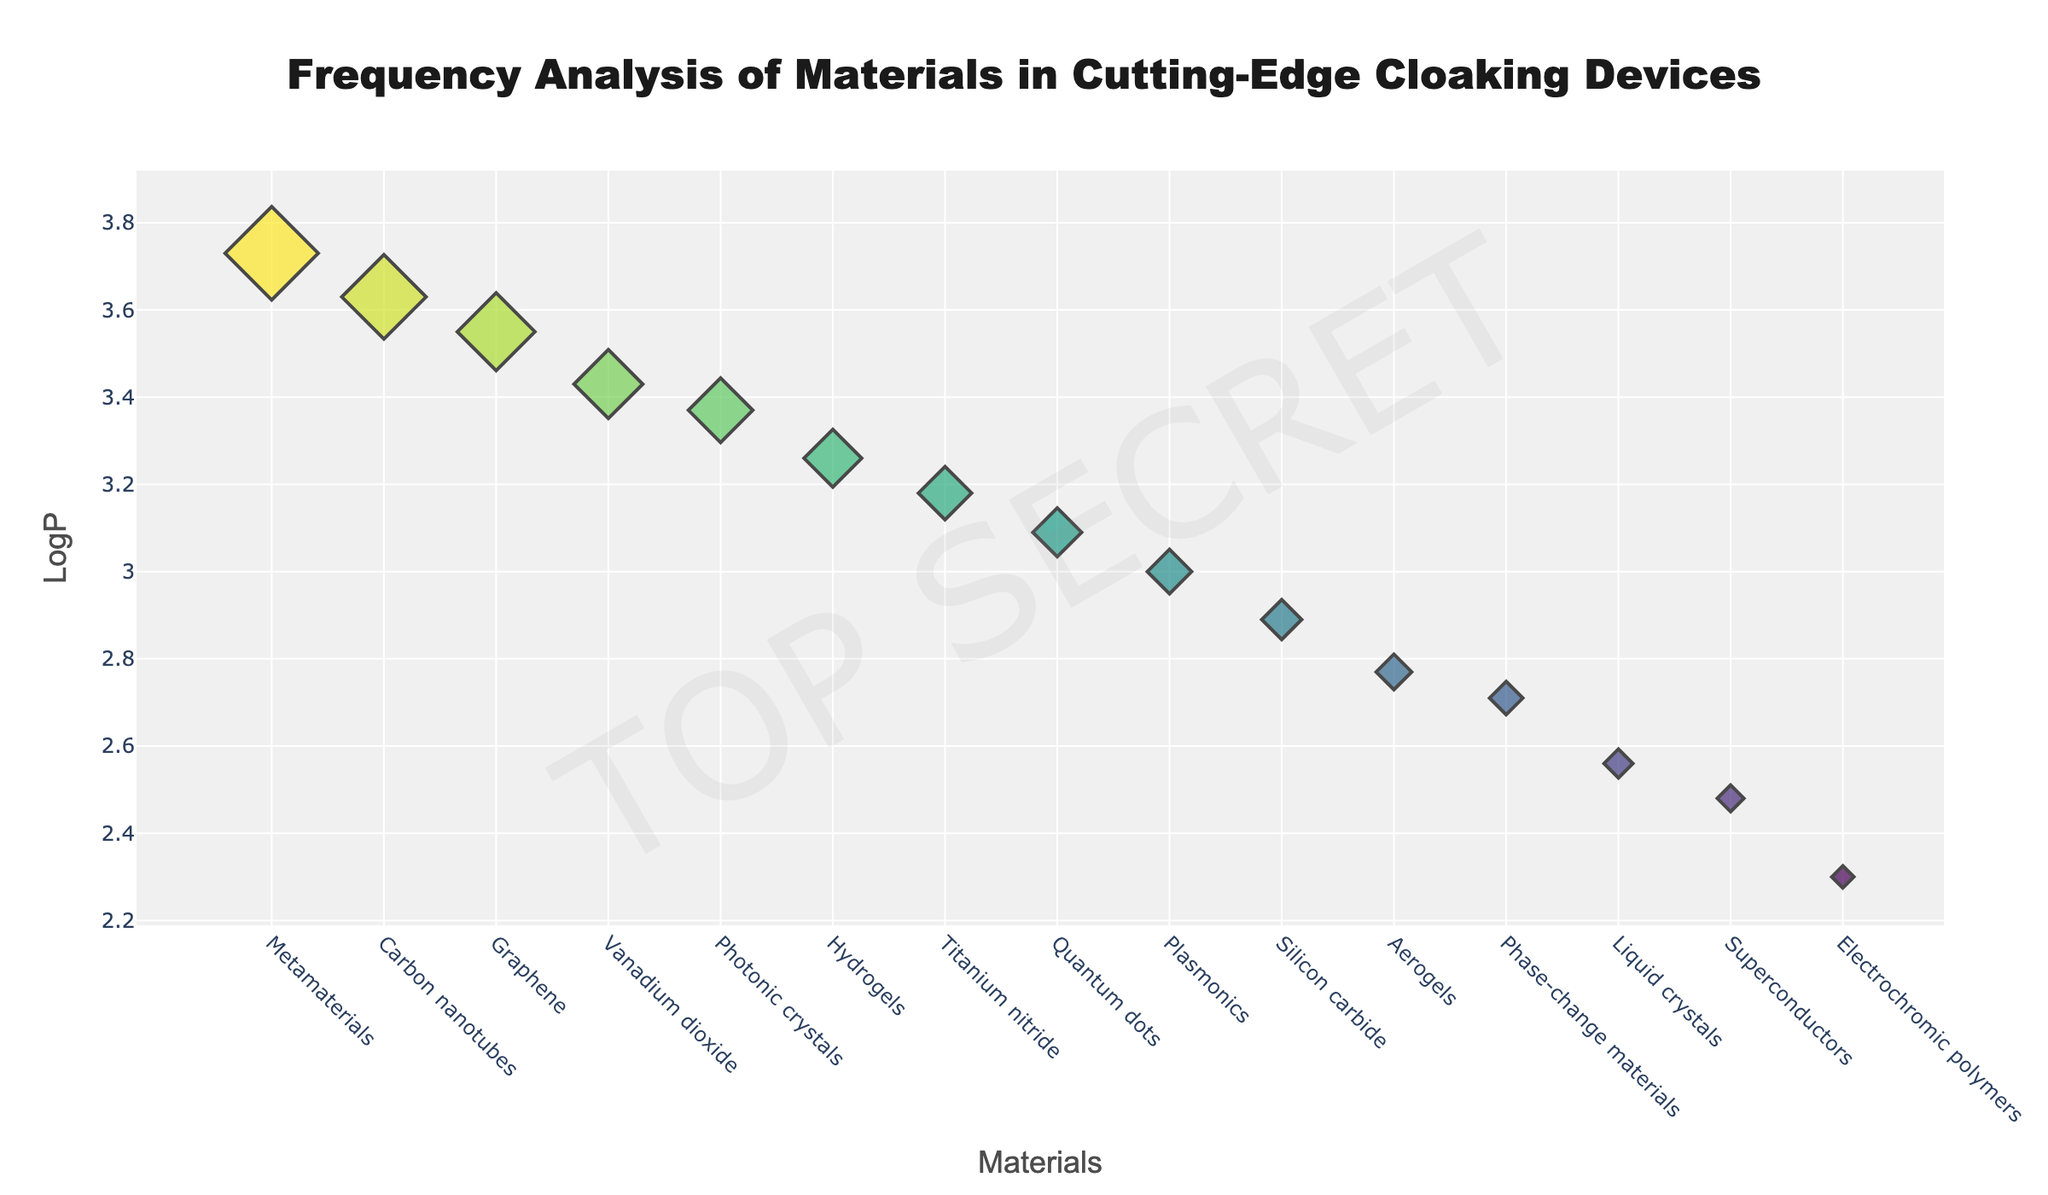What is the title of the figure? The title is prominently displayed at the top of the figure in large, bold font. It reads: "Frequency Analysis of Materials in Cutting-Edge Cloaking Devices."
Answer: Frequency Analysis of Materials in Cutting-Edge Cloaking Devices What material has the highest LogP value in the plot? By examining the y-axis values and the corresponding data points, the highest LogP value is approximately 3.73, which corresponds to "Metamaterials."
Answer: Metamaterials How many materials have a LogP value greater than 3.00? Looking at the y-axis and identifying data points above 3.00, there are five materials: Metamaterials, Carbon nanotubes, Graphene, Vanadium dioxide, and Photonic crystals.
Answer: 5 Which material is indicated with the largest marker size, and what does it represent? The marker size represents the frequency of the material. The largest marker size on the plot corresponds to "Metamaterials" with a frequency of 42.
Answer: Metamaterials, 42 Compare the LogP values of Graphene and Silicon carbide. Which one is higher, and by how much? Graphene has a LogP value of 3.55, and Silicon carbide has a LogP value of 2.89. The difference is 3.55 - 2.89 = 0.66.
Answer: Graphene, 0.66 Which material has a lower frequency, Aerogels or Quantum dots? By comparing the marker sizes and hover text, Aerogels have a frequency of 16, and Quantum dots have a frequency of 22. Therefore, Aerogels have a lower frequency.
Answer: Aerogels What is the average LogP value of materials with a frequency of at least 20? Materials with a frequency of at least 20 are Metamaterials (LogP 3.73), Carbon nanotubes (LogP 3.63), Graphene (LogP 3.55), Vanadium dioxide (LogP 3.43), Photonic crystals (LogP 3.37), Titanium nitride (LogP 3.18), and Quantum dots (LogP 3.09). The average is (3.73 + 3.63 + 3.55 + 3.43 + 3.37 + 3.18 + 3.09)/7 = 3.42.
Answer: 3.42 Which two materials have the closest LogP values, and what are those values? By inspecting the y-axis values closely, the closest LogP values belong to "Superconductors" (2.48) and "Electrochromic polymers" (2.30), with a difference of 2.48 - 2.30 = 0.18.
Answer: Superconductors and Electrochromic polymers, 2.48 and 2.30 What material has the lowest LogP value in the plot, and what is its frequency? The material with the lowest LogP value is "Electrochromic polymers" with a LogP of 2.30. The frequency for this material is 10.
Answer: Electrochromic polymers, 10 Which material's marker appears just below the "TOP SECRET" watermark, and what is its LogP value? The marker above the "O" in "TOP SECRET" corresponds to "Phase-change materials." The LogP value for Phase-change materials is 2.71.
Answer: Phase-change materials, 2.71 